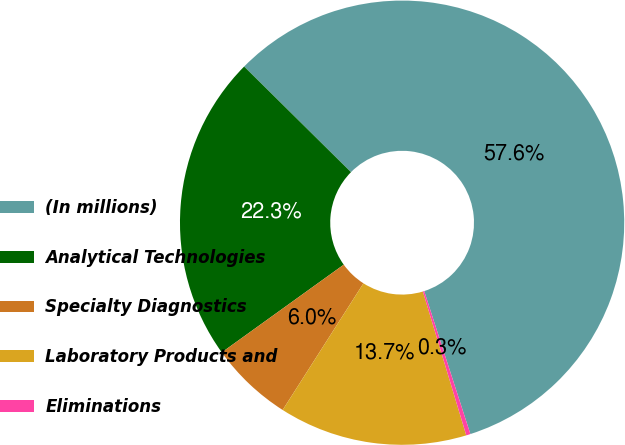Convert chart to OTSL. <chart><loc_0><loc_0><loc_500><loc_500><pie_chart><fcel>(In millions)<fcel>Analytical Technologies<fcel>Specialty Diagnostics<fcel>Laboratory Products and<fcel>Eliminations<nl><fcel>57.62%<fcel>22.33%<fcel>6.04%<fcel>13.7%<fcel>0.31%<nl></chart> 